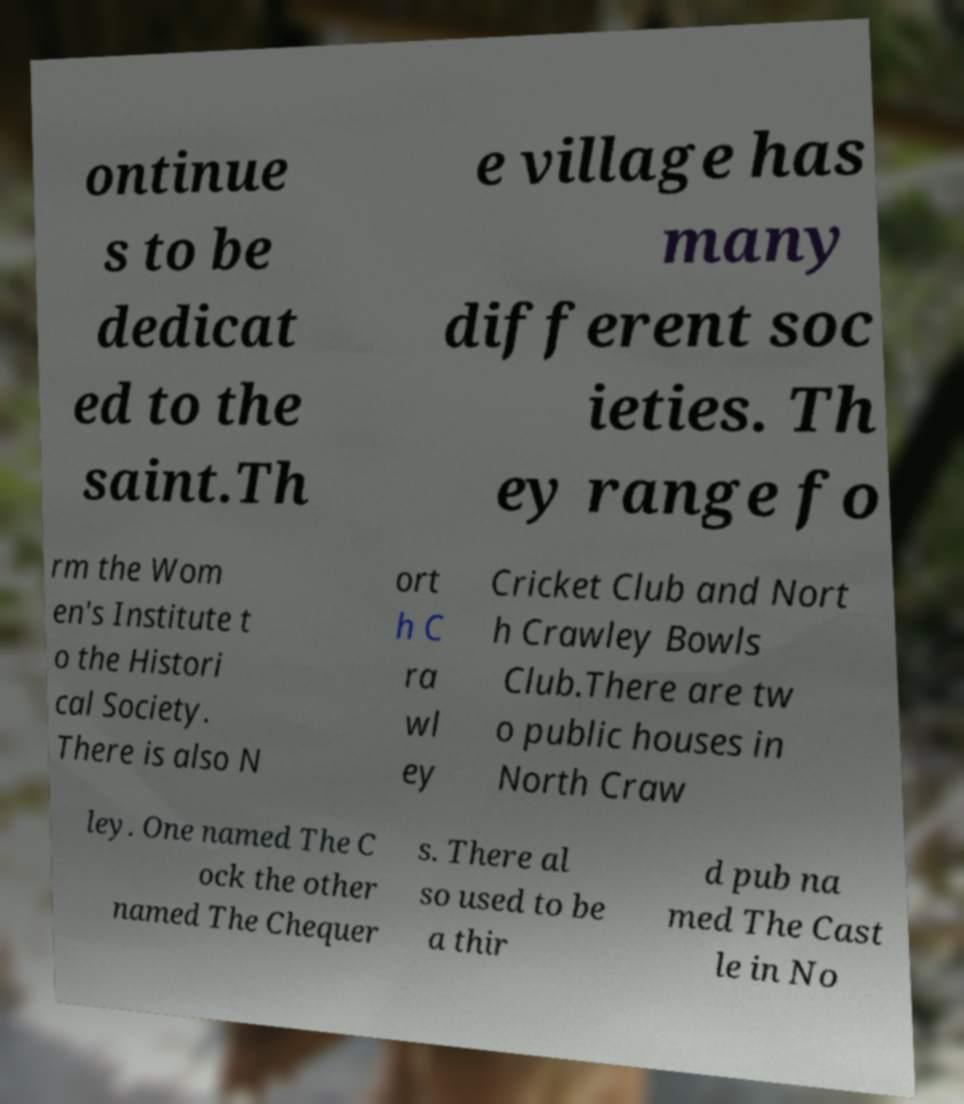Can you read and provide the text displayed in the image?This photo seems to have some interesting text. Can you extract and type it out for me? ontinue s to be dedicat ed to the saint.Th e village has many different soc ieties. Th ey range fo rm the Wom en's Institute t o the Histori cal Society. There is also N ort h C ra wl ey Cricket Club and Nort h Crawley Bowls Club.There are tw o public houses in North Craw ley. One named The C ock the other named The Chequer s. There al so used to be a thir d pub na med The Cast le in No 